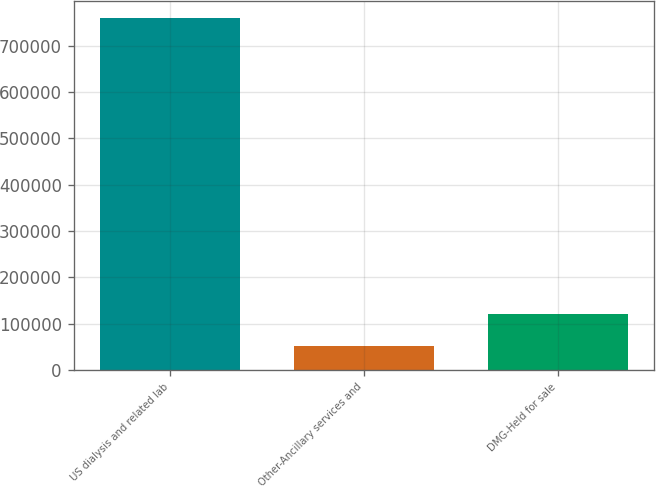Convert chart to OTSL. <chart><loc_0><loc_0><loc_500><loc_500><bar_chart><fcel>US dialysis and related lab<fcel>Other-Ancillary services and<fcel>DMG-Held for sale<nl><fcel>759218<fcel>50891<fcel>121724<nl></chart> 